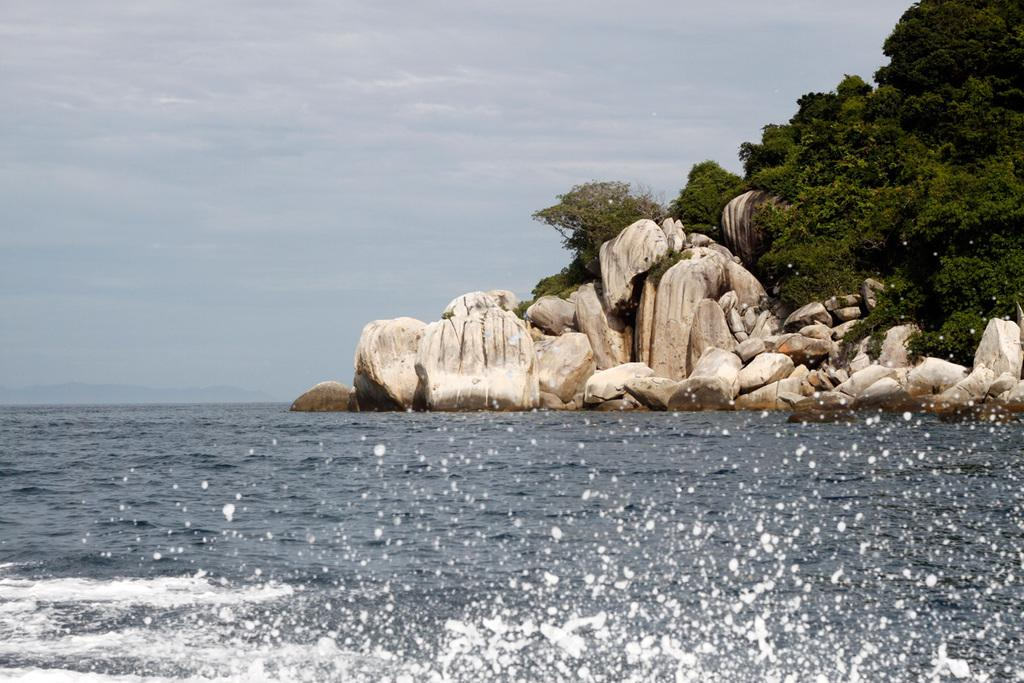What type of natural environment is depicted in the image? The image features many trees and rocks, suggesting a natural setting. What is the condition of the sky in the image? The sky is cloudy in the image. What can be seen at the bottom of the image? There is water visible at the bottom of the image. What type of brass pan can be seen being used for treatment in the image? There is no brass pan or any treatment being depicted in the image; it features trees, rocks, a cloudy sky, and water. 